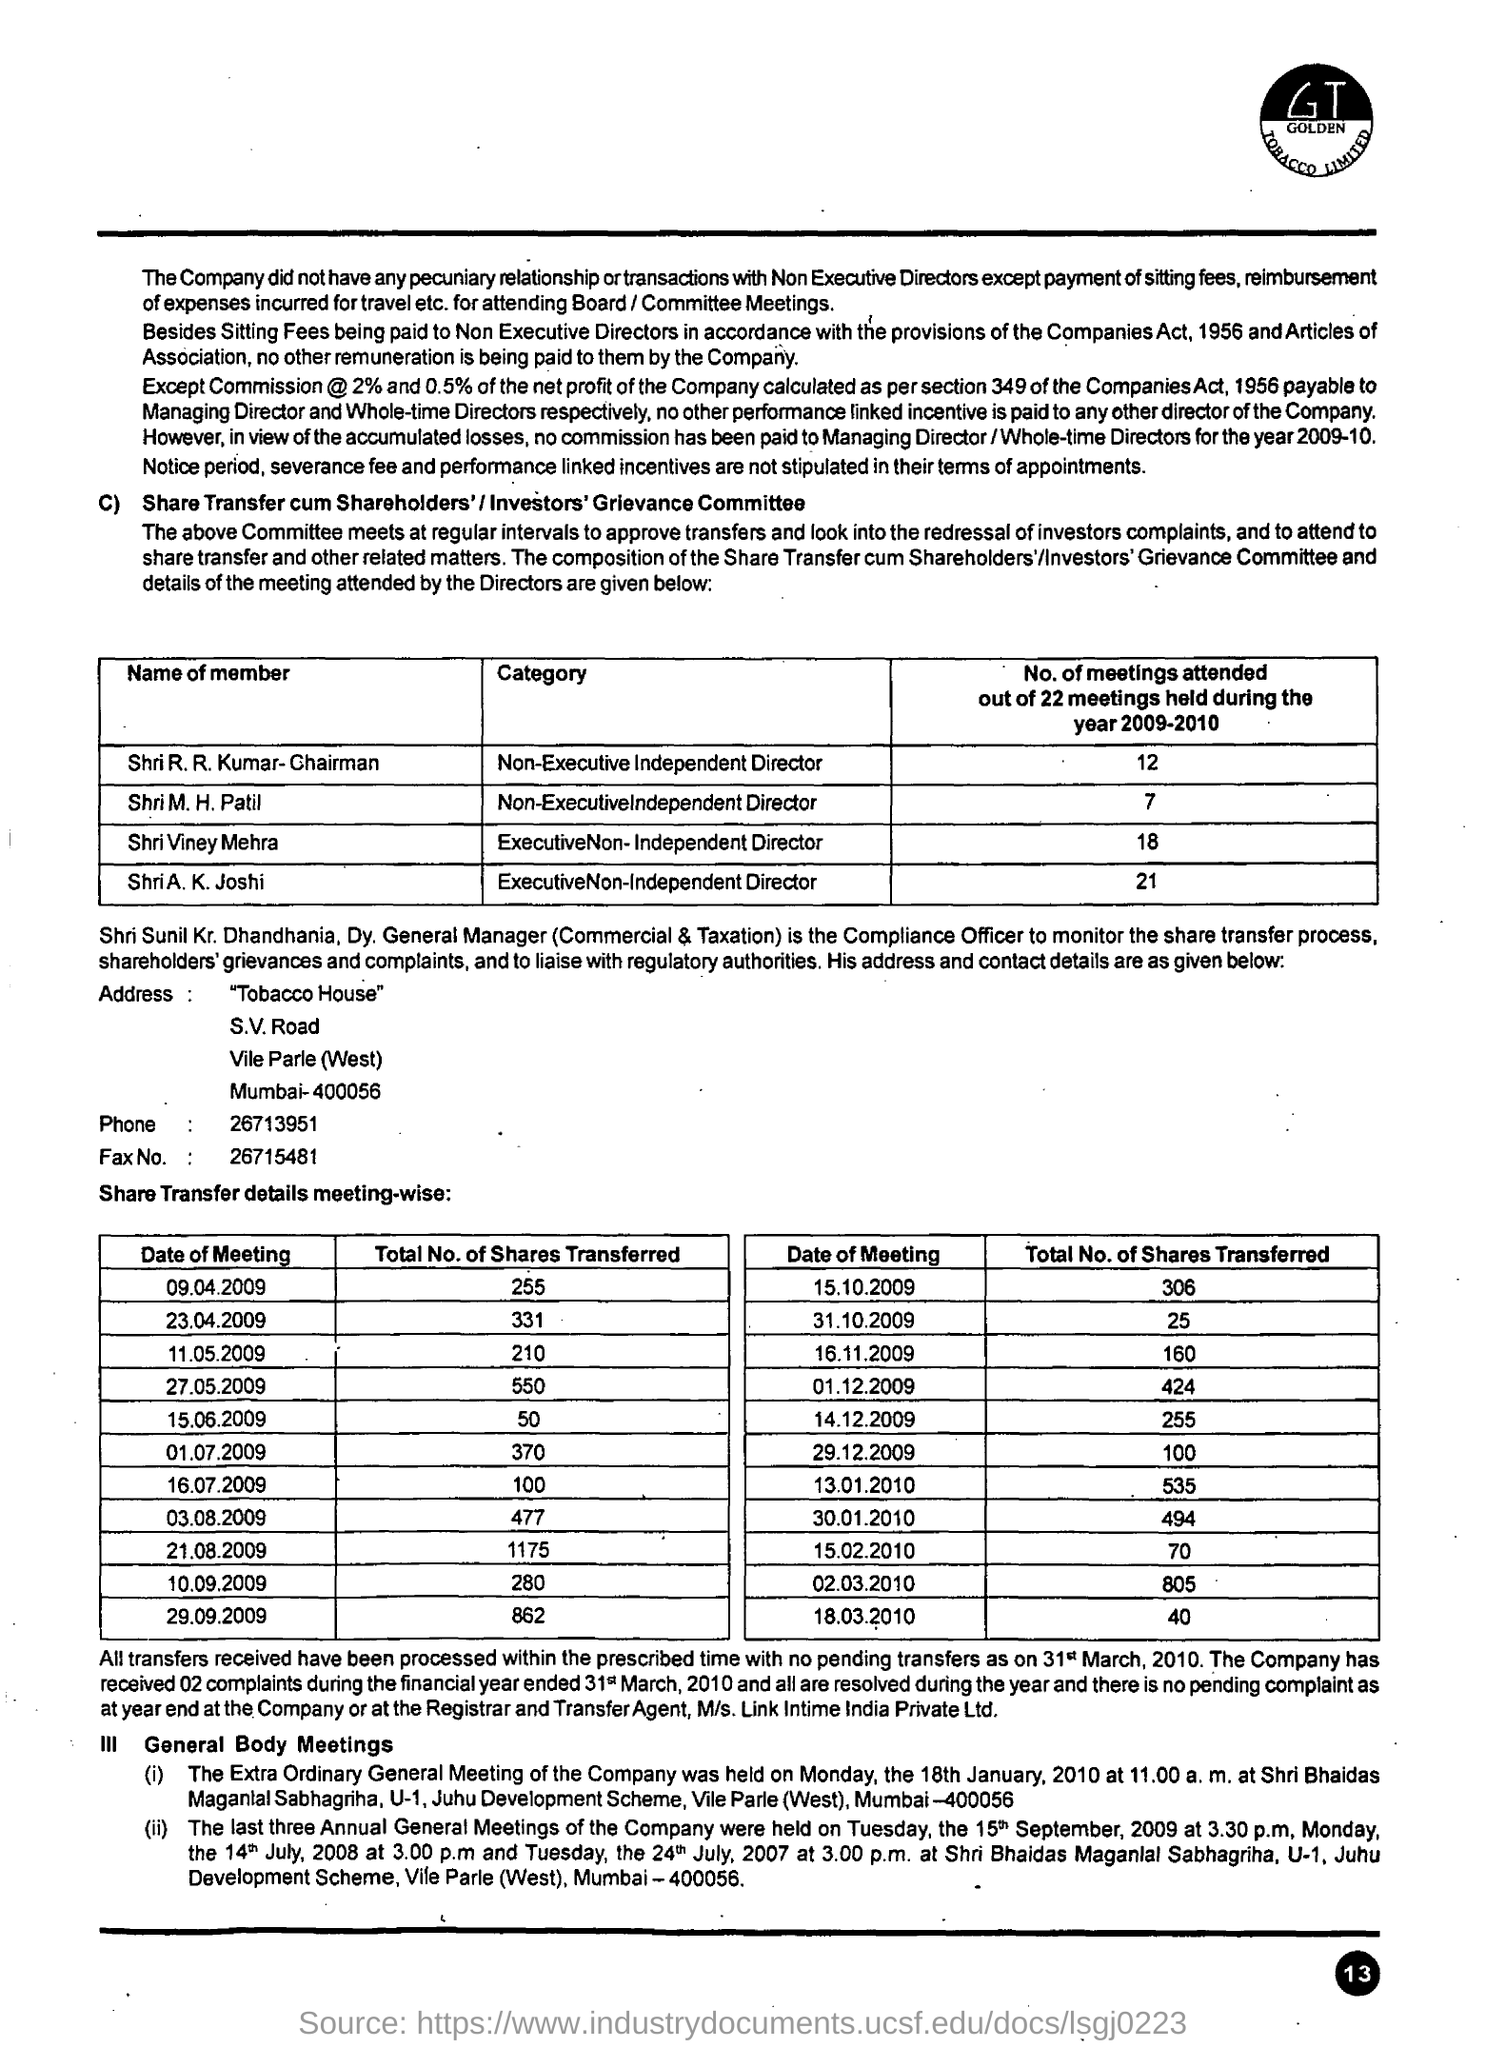Indicate a few pertinent items in this graphic. There was a meeting attended by Shri M. H. Patil in the year 2009-2010. 